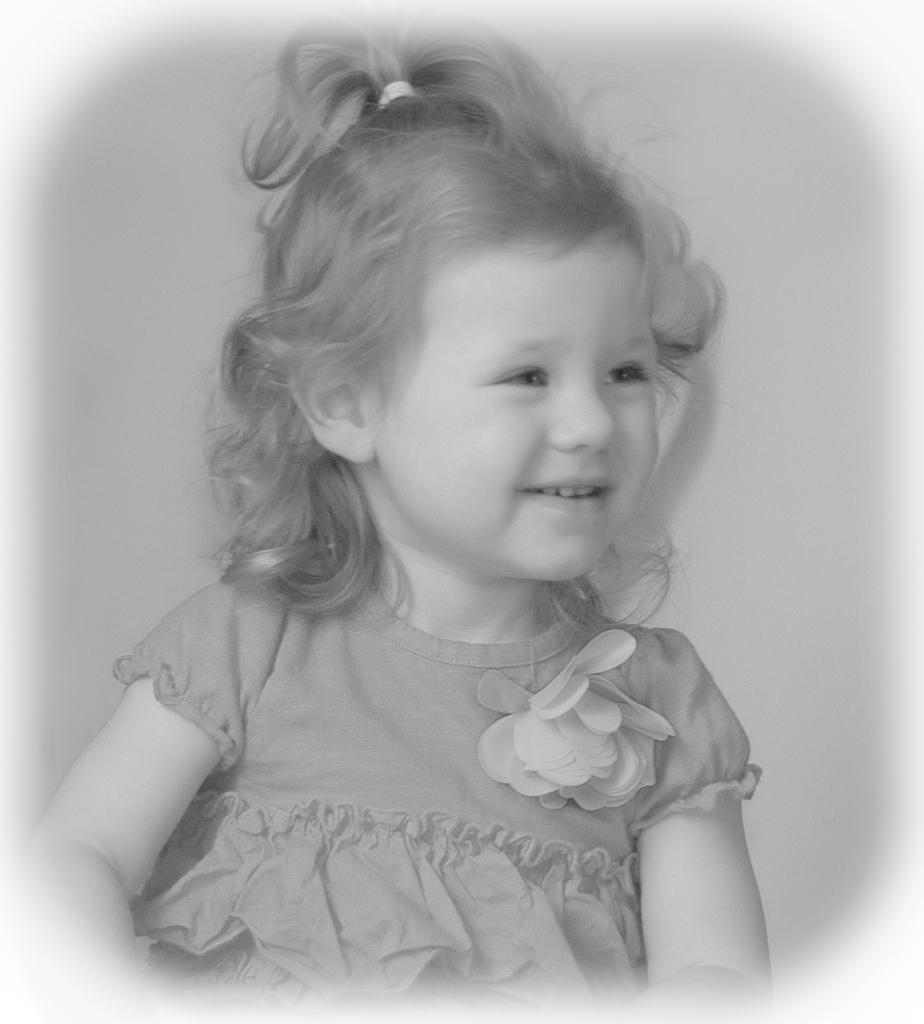What is the main subject of the image? The main subject of the image is a kid. What can be observed about the kid's attire? The kid is wearing clothes. What type of camera is the kid using in the image? There is no camera present in the image, and therefore no such activity can be observed. 